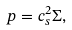Convert formula to latex. <formula><loc_0><loc_0><loc_500><loc_500>p = c _ { s } ^ { 2 } \Sigma ,</formula> 